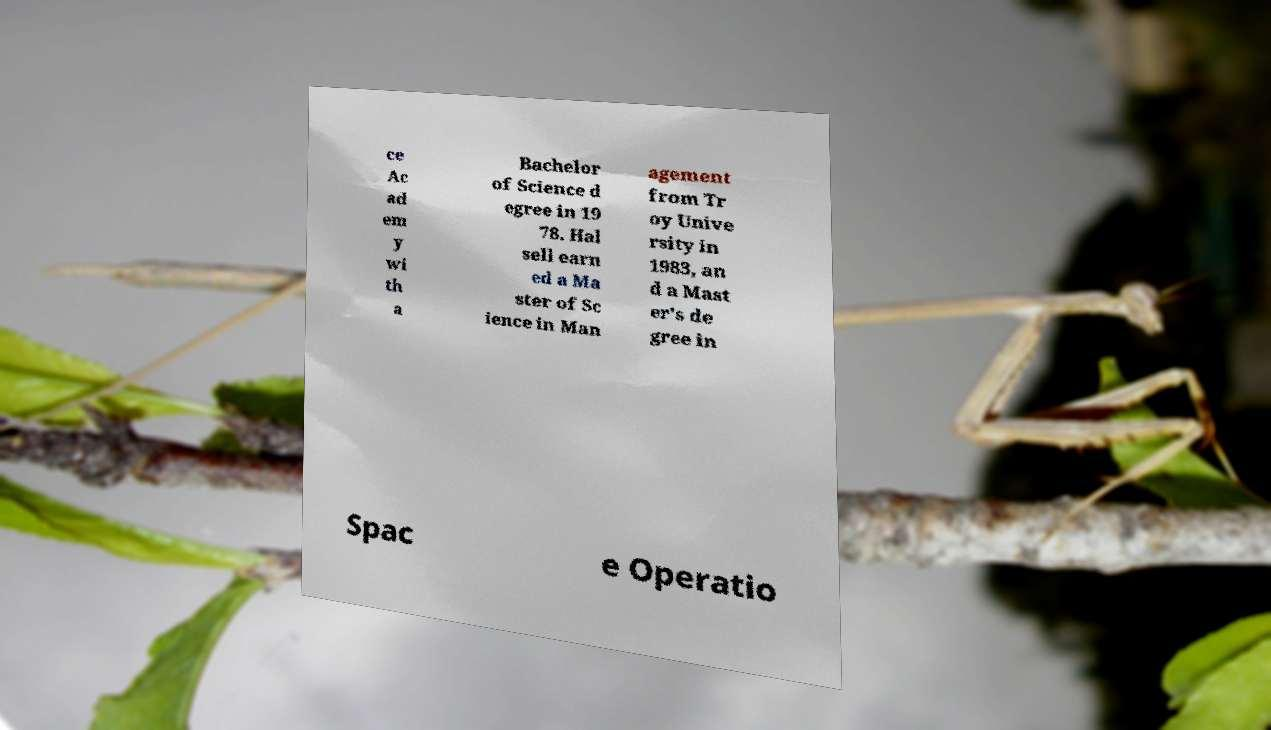Can you accurately transcribe the text from the provided image for me? ce Ac ad em y wi th a Bachelor of Science d egree in 19 78. Hal sell earn ed a Ma ster of Sc ience in Man agement from Tr oy Unive rsity in 1983, an d a Mast er's de gree in Spac e Operatio 